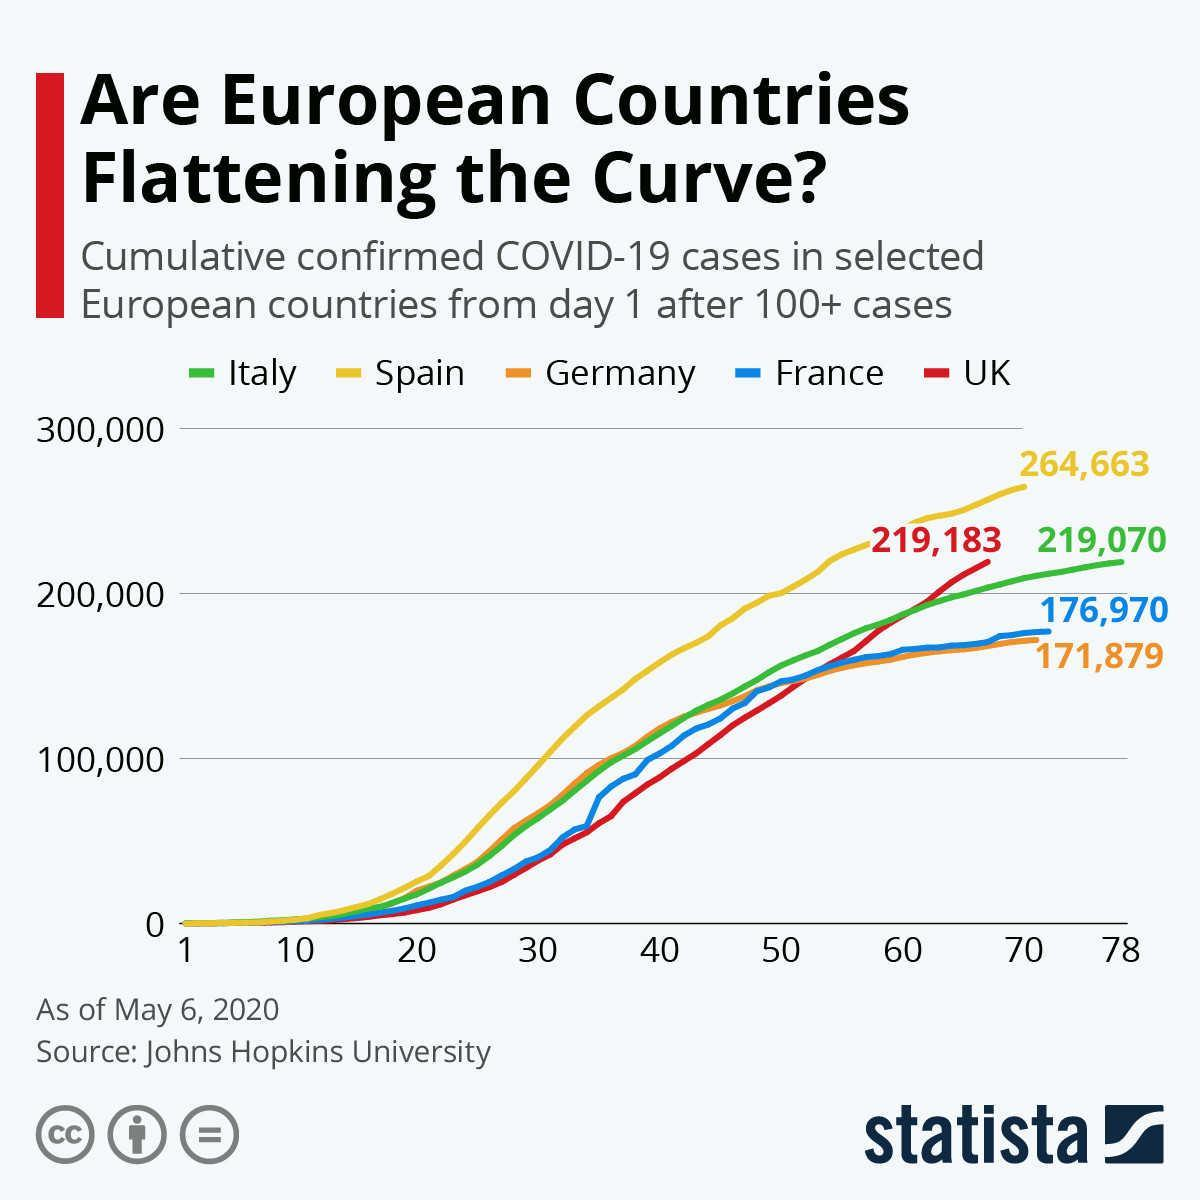Which country is represented by green coloured line?
Answer the question with a short phrase. Italy Which countries had cumulative cases less than 200,000? France, Germany By which colour is the cumulative cases of UK represented- red, yellow or blue? red What is the difference between cases in Spain and Germany? 92,784 Which country has the highest cumulative confirmed cases as of May 6, 2020? Spain How many countries had cases above 200,000? 3 Which country had 264,663 covid cases as of May 6, 2020? Spain What is the cumulative confirmed covid cases for Italy from the graph? 219,070 How many countries had cases below 200,000? 2 Which countries had cumulative cases cross 2,00,000? Spain, UK, Italy 